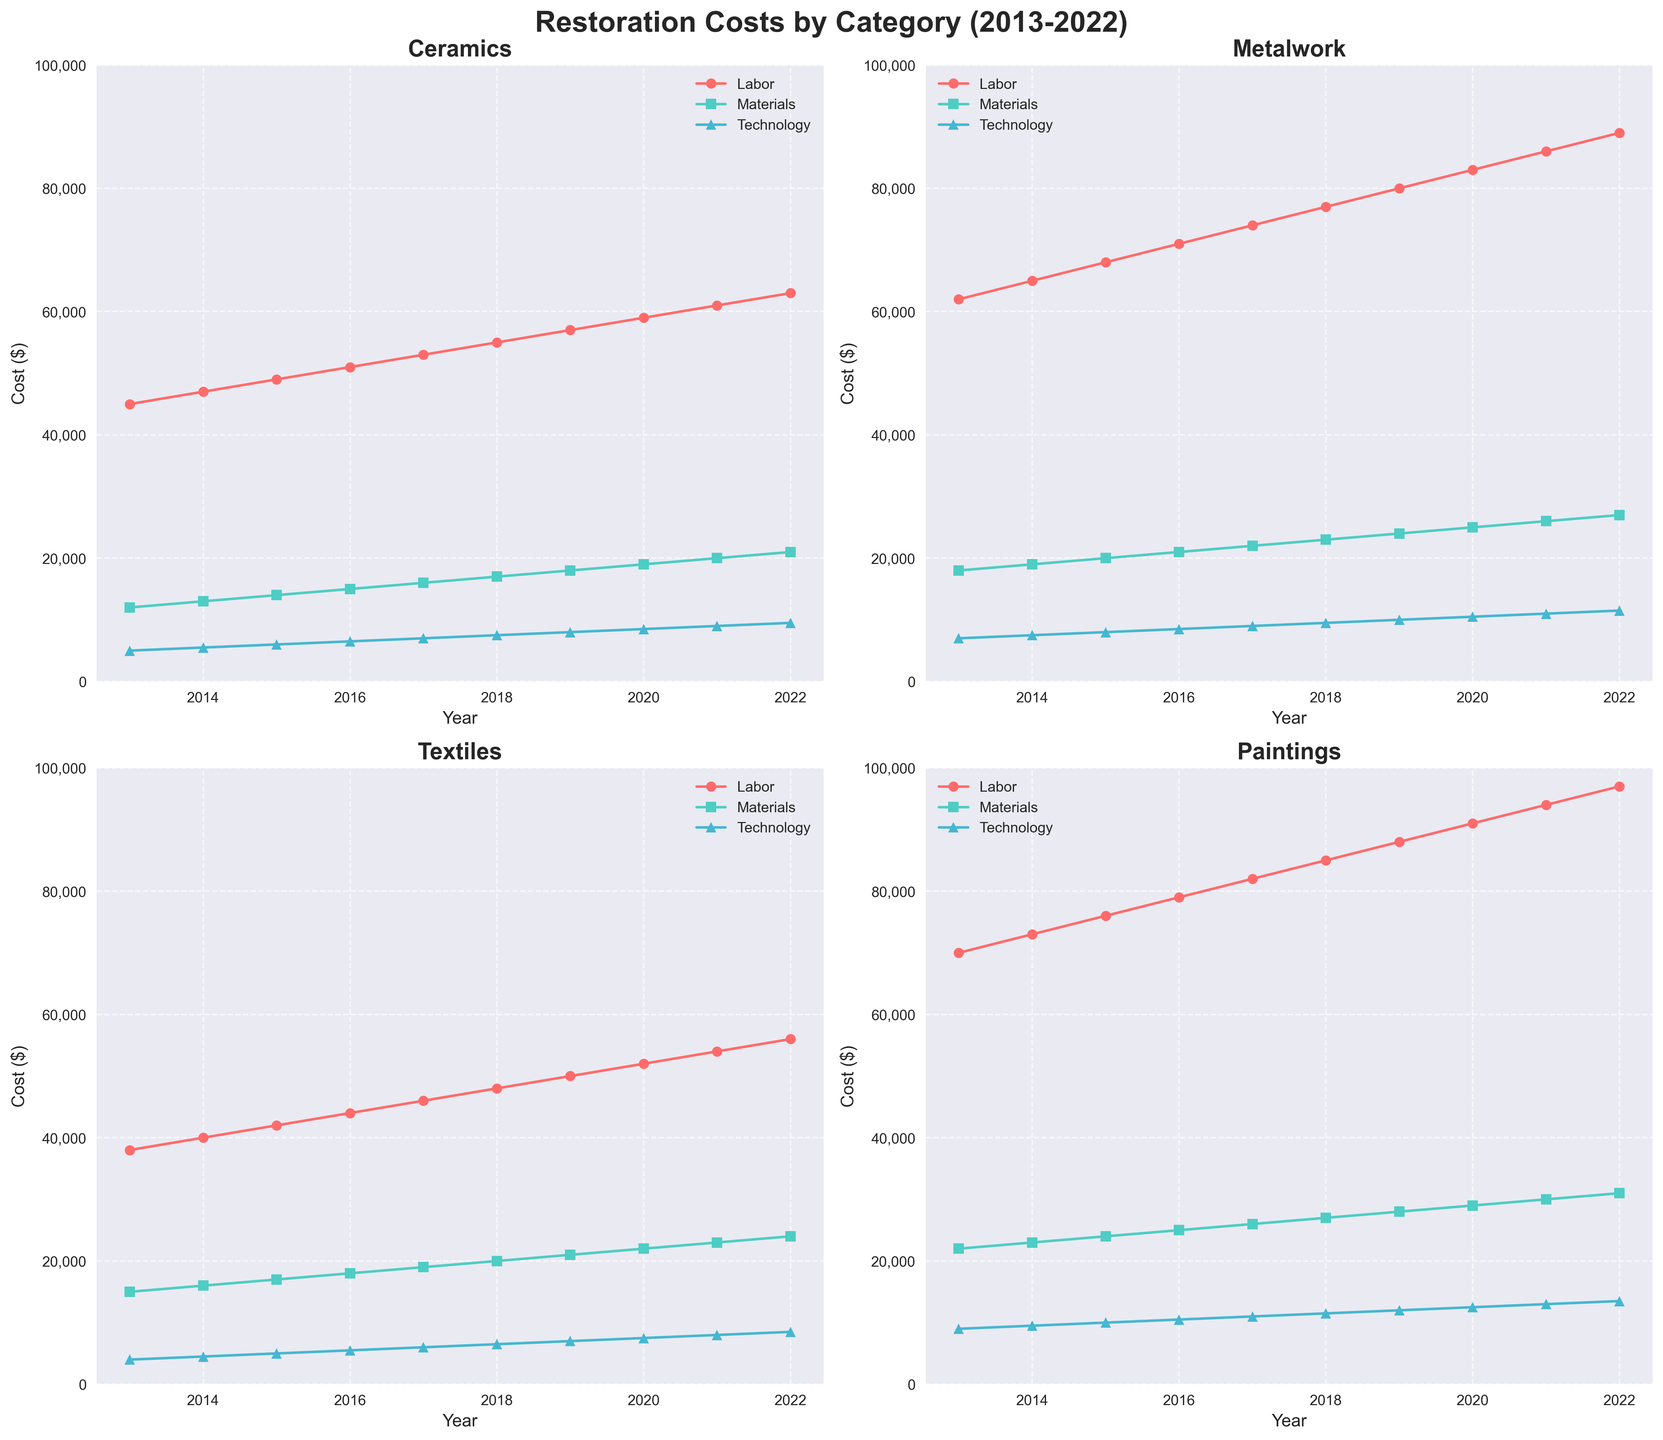Which category had the highest technology cost in 2022? To find the highest technology cost, we compare the data points for technology costs in 2022 across all four categories. The value for Paintings is the highest at $13,500.
Answer: Paintings In 2016, which category spent more on materials, Textiles or Metalwork? We need to compare the materials costs for Textiles and Metalwork in 2016. Metalwork spent $21,000 and Textiles spent $18,000, so Metalwork spent more.
Answer: Metalwork Between 2013 and 2022, which category saw the largest increase in labor costs? Calculate the difference in labor costs between 2013 and 2022 for each category. Ceramics increased by $18,000, Metalwork by $27,000, Textiles by $18,000, and Paintings by $27,000. Both Metalwork and Paintings saw the largest increase of $27,000.
Answer: Metalwork and Paintings Which category had the smallest total cost in 2019? To find the smallest total cost, sum the labor, materials, and technology costs for each category in 2019. The totals are: Ceramics ($57,000 + $18,000 + $8,000 = $83,000), Metalwork ($80,000 + $24,000 + $10,000 = $114,000), Textiles ($50,000 + $21,000 + $7,000 = $78,000), Paintings ($88,000 + $28,000 + $12,000 = $128,000). Textiles had the smallest total cost.
Answer: Textiles How did the technology cost for Ceramics change from 2013 to 2022? We observe the technology costs for Ceramics in 2013 and 2022, which are $5,000 and $9,500, respectively. The change is $9,500 - $5,000 = $4,500.
Answer: Increased by $4,500 What was the average labor cost for Metalwork over the past decade? Add the labor costs for Metalwork from 2013 to 2022 and divide by 10. The total is $62,000 + $65,000 + $68,000 + $71,000 + $74,000 + $77,000 + $80,000 + $83,000 + $86,000 + $89,000 = $755,000. Average is $755,000 / 10 = $75,500.
Answer: $75,500 Which year did Paintings have the lowest materials cost? Compare the materials costs for Paintings across each year. The lowest value is $22,000 in 2013.
Answer: 2013 Did the labor costs for Textiles ever exceed those for Ceramics in any year? Compare the labor costs for Textiles and Ceramics each year from 2013 to 2022. There is no year where Textiles' labor costs exceed those of Ceramics.
Answer: No Compare the average technology cost for Paintings and Metalwork over the decade. Which category had a higher average? Calculate the average technology cost for each over 10 years. For Paintings: (9000+9500+10000+10500+11000+11500+12000+12500+13000+13500)/10 = $11,650. For Metalwork: (7000+7500+8000+8500+9000+9500+10000+10500+11000+11500)/10 = $9,500. Paintings had a higher average.
Answer: Paintings In 2018, which category's technology cost is closest to the average technology cost of all categories combined? Find the total technology costs in 2018 ($7,500 + $9,500 + $6,500 + $11,500 = $35,000), and the average ($35,000 / 4 = $8,750). Compare technology costs to $8,750: Ceramics ($7,500), Metalwork ($9,500), Textiles ($6,500), Paintings ($11,500). Metalwork ($9,500) is closest.
Answer: Metalwork 